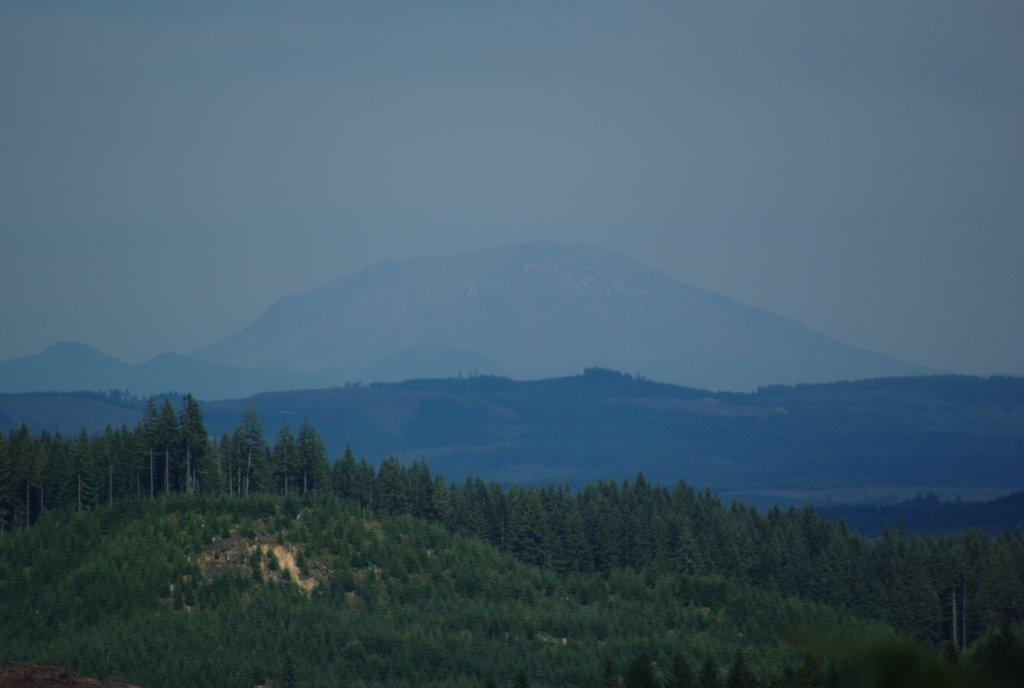What type of vegetation can be seen in the image? There are plants and trees in the image. What type of landscape feature is visible in the image? There are hills visible in the image. What part of the natural environment is visible in the image? The sky is visible in the image. Can you tell me where the fruit is located in the image? There is no fruit present in the image. What type of animals can be seen at the zoo in the image? There is no zoo present in the image. 